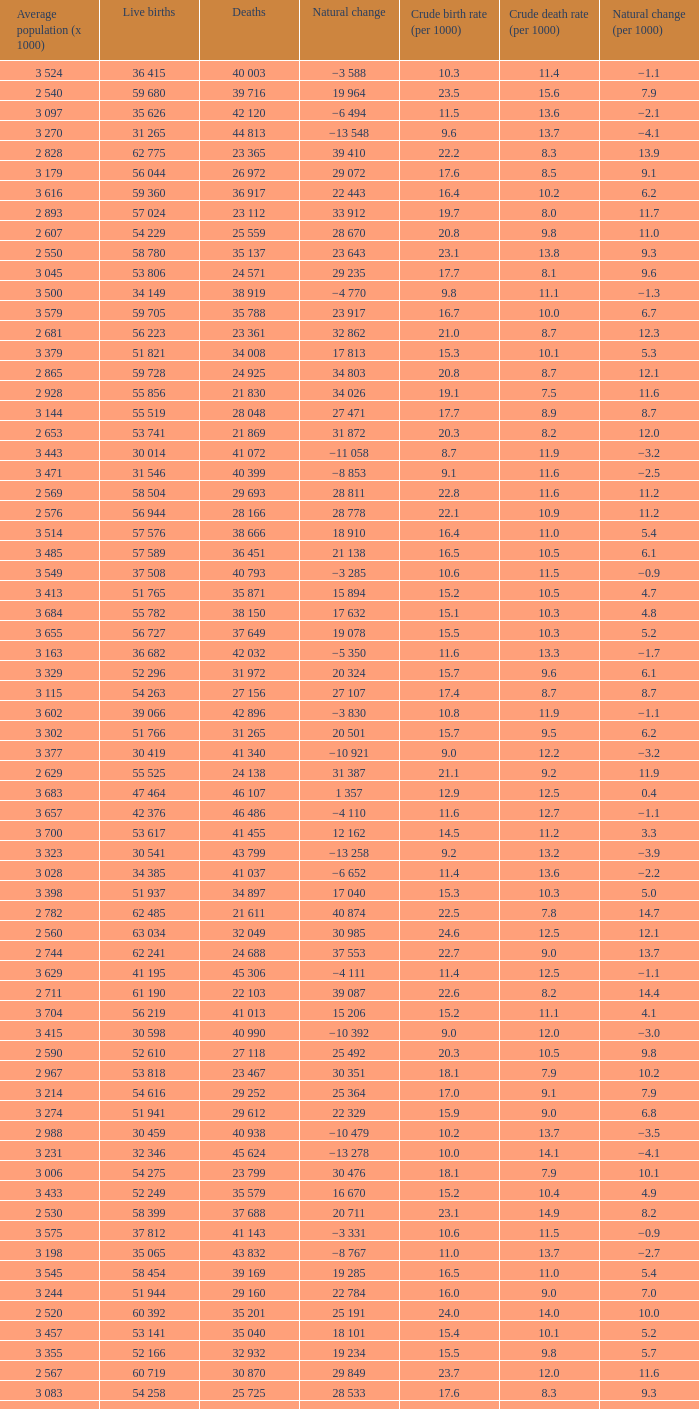Which Average population (x 1000) has a Crude death rate (per 1000) smaller than 10.9, and a Crude birth rate (per 1000) smaller than 19.7, and a Natural change (per 1000) of 8.7, and Live births of 54 263? 3 115. 